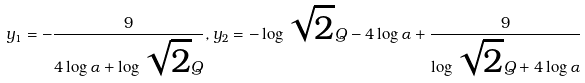Convert formula to latex. <formula><loc_0><loc_0><loc_500><loc_500>y _ { 1 } = - \frac { 9 } { 4 \log \alpha + \log \sqrt { 2 } Q } , y _ { 2 } = - \log \sqrt { 2 } Q - 4 \log \alpha + \frac { 9 } { \log \sqrt { 2 } Q + 4 \log \alpha }</formula> 